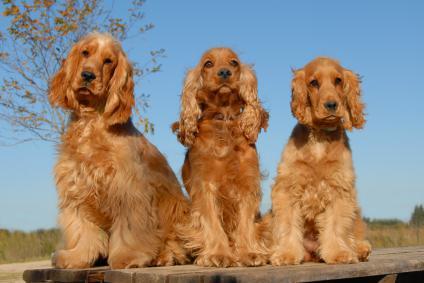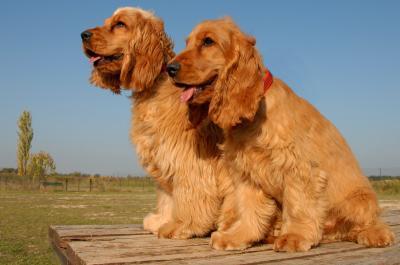The first image is the image on the left, the second image is the image on the right. Examine the images to the left and right. Is the description "An image shows exactly two red-orange dogs side-by-side." accurate? Answer yes or no. Yes. The first image is the image on the left, the second image is the image on the right. Given the left and right images, does the statement "All dogs wear a leash or collar." hold true? Answer yes or no. No. 